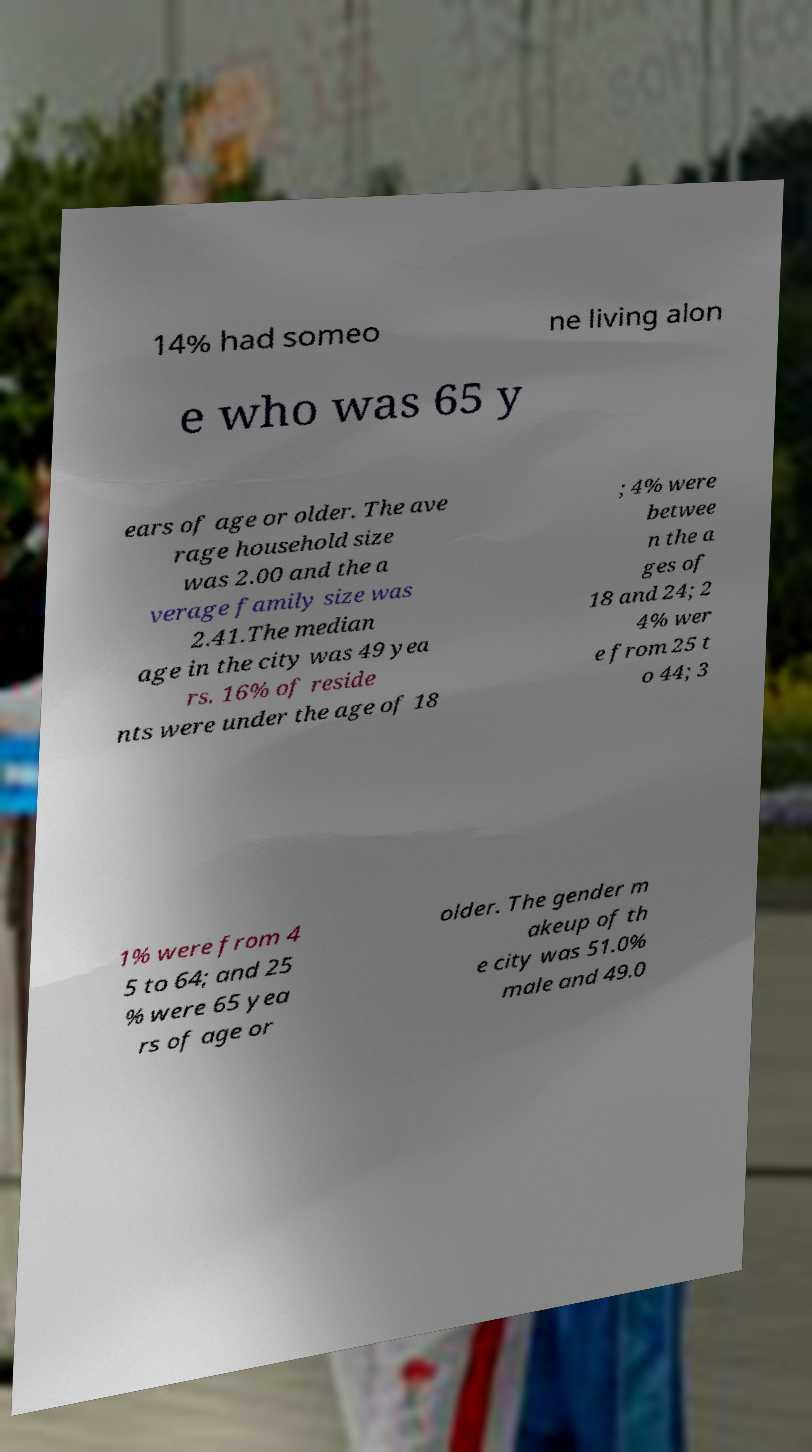Can you accurately transcribe the text from the provided image for me? 14% had someo ne living alon e who was 65 y ears of age or older. The ave rage household size was 2.00 and the a verage family size was 2.41.The median age in the city was 49 yea rs. 16% of reside nts were under the age of 18 ; 4% were betwee n the a ges of 18 and 24; 2 4% wer e from 25 t o 44; 3 1% were from 4 5 to 64; and 25 % were 65 yea rs of age or older. The gender m akeup of th e city was 51.0% male and 49.0 